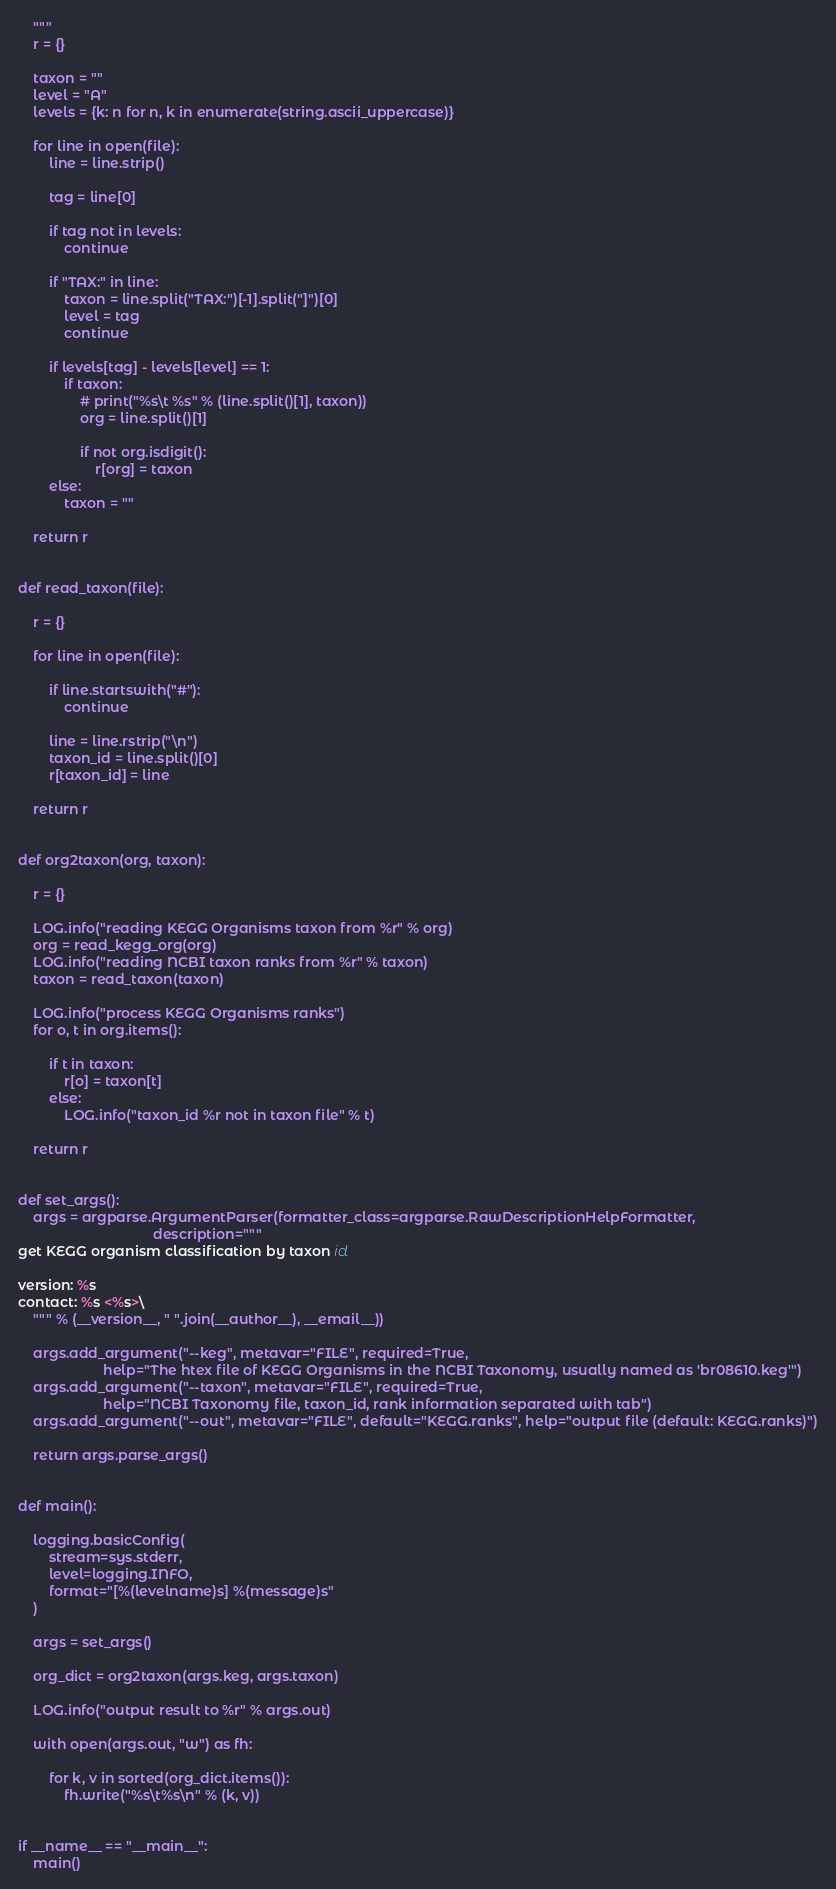Convert code to text. <code><loc_0><loc_0><loc_500><loc_500><_Python_>    """
    r = {}

    taxon = ""
    level = "A"
    levels = {k: n for n, k in enumerate(string.ascii_uppercase)}

    for line in open(file):
        line = line.strip()

        tag = line[0]

        if tag not in levels:
            continue

        if "TAX:" in line:
            taxon = line.split("TAX:")[-1].split("]")[0]
            level = tag
            continue

        if levels[tag] - levels[level] == 1:
            if taxon:
                # print("%s\t %s" % (line.split()[1], taxon))
                org = line.split()[1]

                if not org.isdigit():
                    r[org] = taxon
        else:
            taxon = ""

    return r


def read_taxon(file):

    r = {}

    for line in open(file):

        if line.startswith("#"):
            continue

        line = line.rstrip("\n")
        taxon_id = line.split()[0]
        r[taxon_id] = line

    return r


def org2taxon(org, taxon):

    r = {}

    LOG.info("reading KEGG Organisms taxon from %r" % org)
    org = read_kegg_org(org)
    LOG.info("reading NCBI taxon ranks from %r" % taxon)
    taxon = read_taxon(taxon)

    LOG.info("process KEGG Organisms ranks")
    for o, t in org.items():

        if t in taxon:
            r[o] = taxon[t]
        else:
            LOG.info("taxon_id %r not in taxon file" % t)

    return r


def set_args():
    args = argparse.ArgumentParser(formatter_class=argparse.RawDescriptionHelpFormatter,
                                   description="""
get KEGG organism classification by taxon id

version: %s
contact: %s <%s>\
    """ % (__version__, " ".join(__author__), __email__))

    args.add_argument("--keg", metavar="FILE", required=True,
                      help="The htex file of KEGG Organisms in the NCBI Taxonomy, usually named as 'br08610.keg'")
    args.add_argument("--taxon", metavar="FILE", required=True,
                      help="NCBI Taxonomy file, taxon_id, rank information separated with tab")
    args.add_argument("--out", metavar="FILE", default="KEGG.ranks", help="output file (default: KEGG.ranks)")

    return args.parse_args()


def main():

    logging.basicConfig(
        stream=sys.stderr,
        level=logging.INFO,
        format="[%(levelname)s] %(message)s"
    )

    args = set_args()

    org_dict = org2taxon(args.keg, args.taxon)

    LOG.info("output result to %r" % args.out)

    with open(args.out, "w") as fh:

        for k, v in sorted(org_dict.items()):
            fh.write("%s\t%s\n" % (k, v))


if __name__ == "__main__":
    main()

</code> 